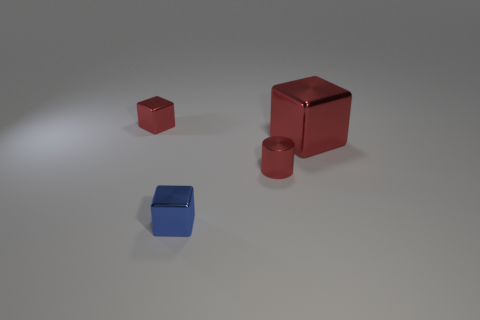There is a tiny block that is in front of the tiny metal cylinder; are there any tiny metallic things to the right of it?
Provide a succinct answer. Yes. There is a red shiny thing that is behind the large block; what shape is it?
Your answer should be very brief. Cube. There is a object on the right side of the tiny metallic cylinder that is in front of the large red shiny thing; what is its color?
Your answer should be compact. Red. How many metal objects have the same size as the red cylinder?
Ensure brevity in your answer.  2. There is a big block that is made of the same material as the tiny blue thing; what is its color?
Your response must be concise. Red. Are there fewer tiny blue blocks than red things?
Offer a terse response. Yes. How many red things are either small shiny cubes or small metallic objects?
Your answer should be compact. 2. How many shiny objects are both behind the tiny blue cube and left of the large metal cube?
Keep it short and to the point. 2. Is the tiny blue block made of the same material as the red cylinder?
Your answer should be compact. Yes. The blue object that is the same size as the red metallic cylinder is what shape?
Give a very brief answer. Cube. 